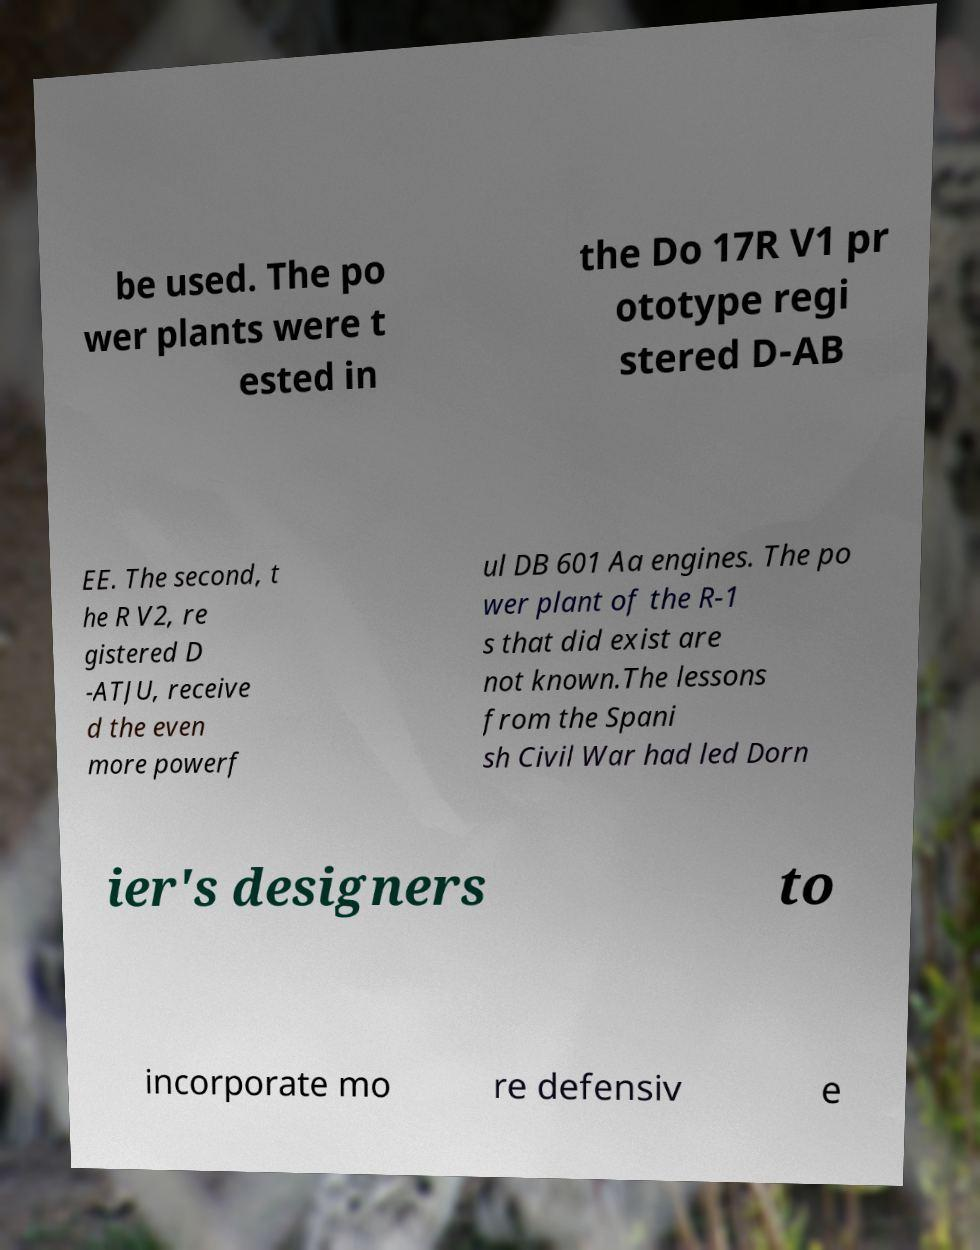For documentation purposes, I need the text within this image transcribed. Could you provide that? be used. The po wer plants were t ested in the Do 17R V1 pr ototype regi stered D-AB EE. The second, t he R V2, re gistered D -ATJU, receive d the even more powerf ul DB 601 Aa engines. The po wer plant of the R-1 s that did exist are not known.The lessons from the Spani sh Civil War had led Dorn ier's designers to incorporate mo re defensiv e 